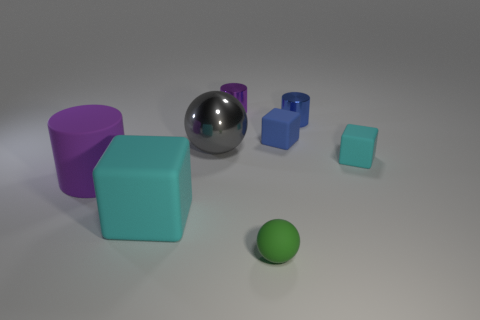Add 2 tiny red things. How many objects exist? 10 Subtract all blocks. How many objects are left? 5 Subtract all cyan rubber blocks. Subtract all big shiny objects. How many objects are left? 5 Add 7 metallic spheres. How many metallic spheres are left? 8 Add 4 matte objects. How many matte objects exist? 9 Subtract 0 red cubes. How many objects are left? 8 